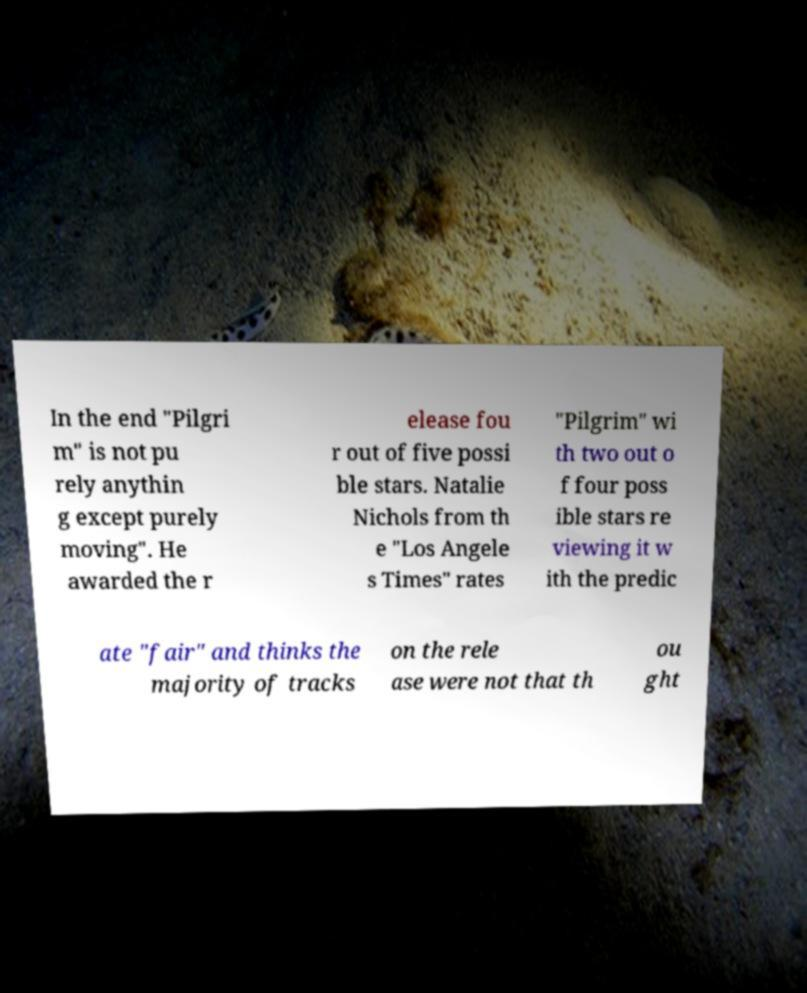Can you accurately transcribe the text from the provided image for me? In the end "Pilgri m" is not pu rely anythin g except purely moving". He awarded the r elease fou r out of five possi ble stars. Natalie Nichols from th e "Los Angele s Times" rates "Pilgrim" wi th two out o f four poss ible stars re viewing it w ith the predic ate "fair" and thinks the majority of tracks on the rele ase were not that th ou ght 